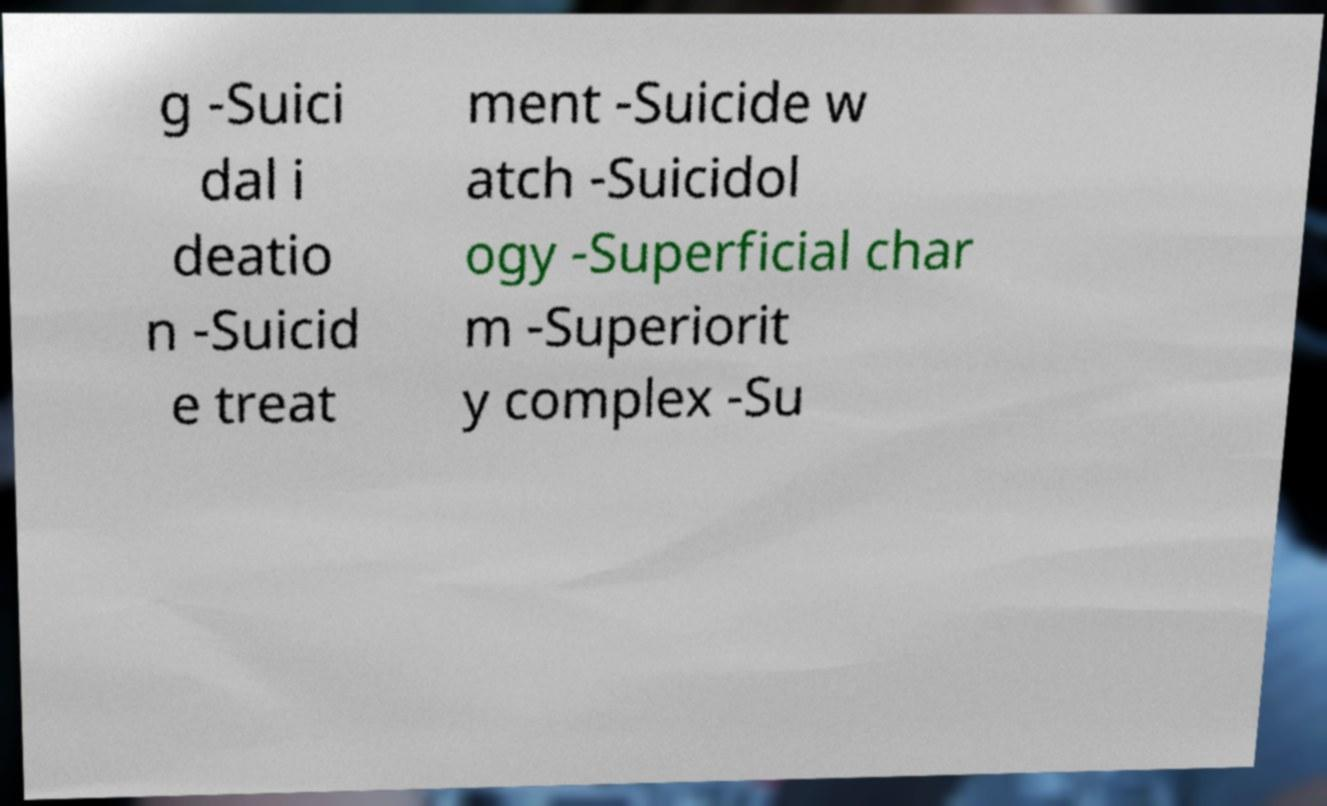Can you accurately transcribe the text from the provided image for me? g -Suici dal i deatio n -Suicid e treat ment -Suicide w atch -Suicidol ogy -Superficial char m -Superiorit y complex -Su 